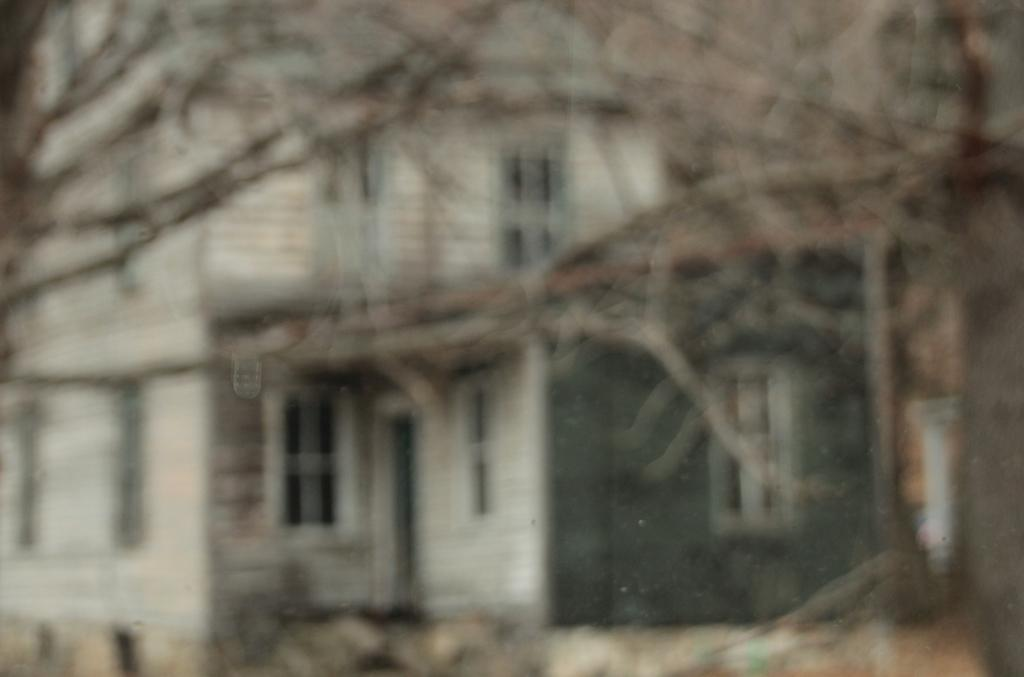What type of vegetation can be seen in the image? There are branches of trees in the image. What type of structure is visible in the image? There is a building with windows in the image. How many crows are sitting on the branches of the trees in the image? There are no crows visible in the image; only branches of trees and a building with windows can be seen. 